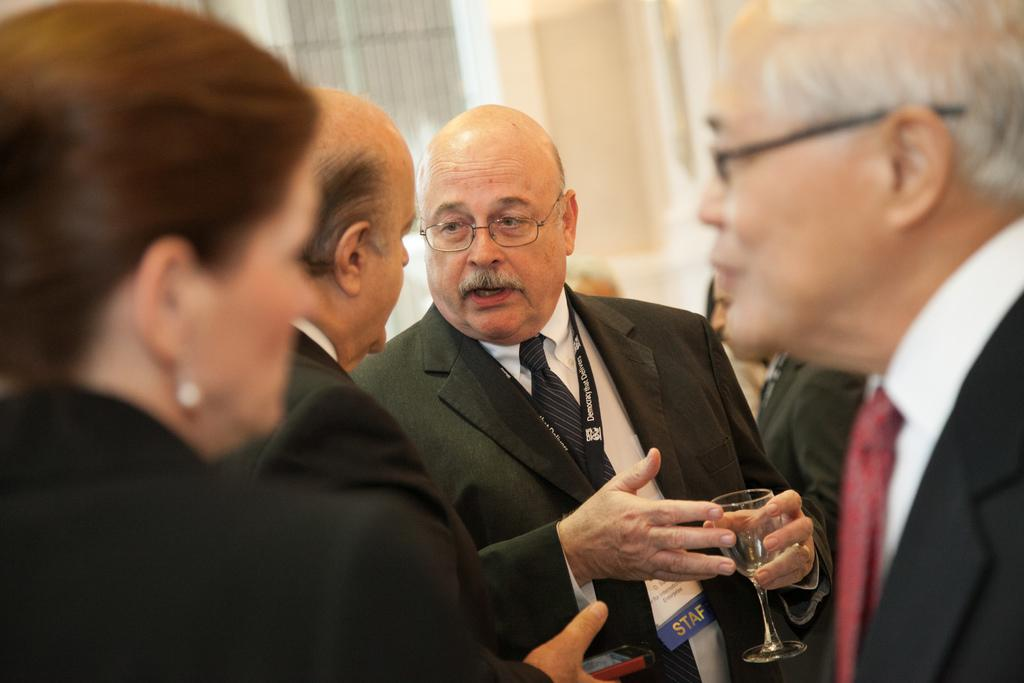How many people are in the image? There is a group of people in the image. Can you describe the attire of one of the individuals? One person is wearing a black color blazer and a white color shirt. What is the person holding in the image? The person is holding a glass. What can be observed about the background of the image? The background of the image is blurred. What type of teeth can be seen in the image? There are no teeth visible in the image. Can you describe the fog in the image? There is no fog present in the image. 